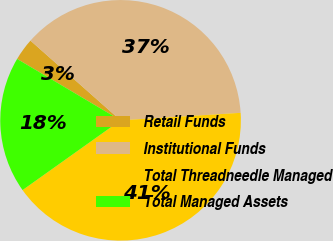Convert chart to OTSL. <chart><loc_0><loc_0><loc_500><loc_500><pie_chart><fcel>Retail Funds<fcel>Institutional Funds<fcel>Total Threadneedle Managed<fcel>Total Managed Assets<nl><fcel>3.0%<fcel>37.48%<fcel>41.15%<fcel>18.37%<nl></chart> 